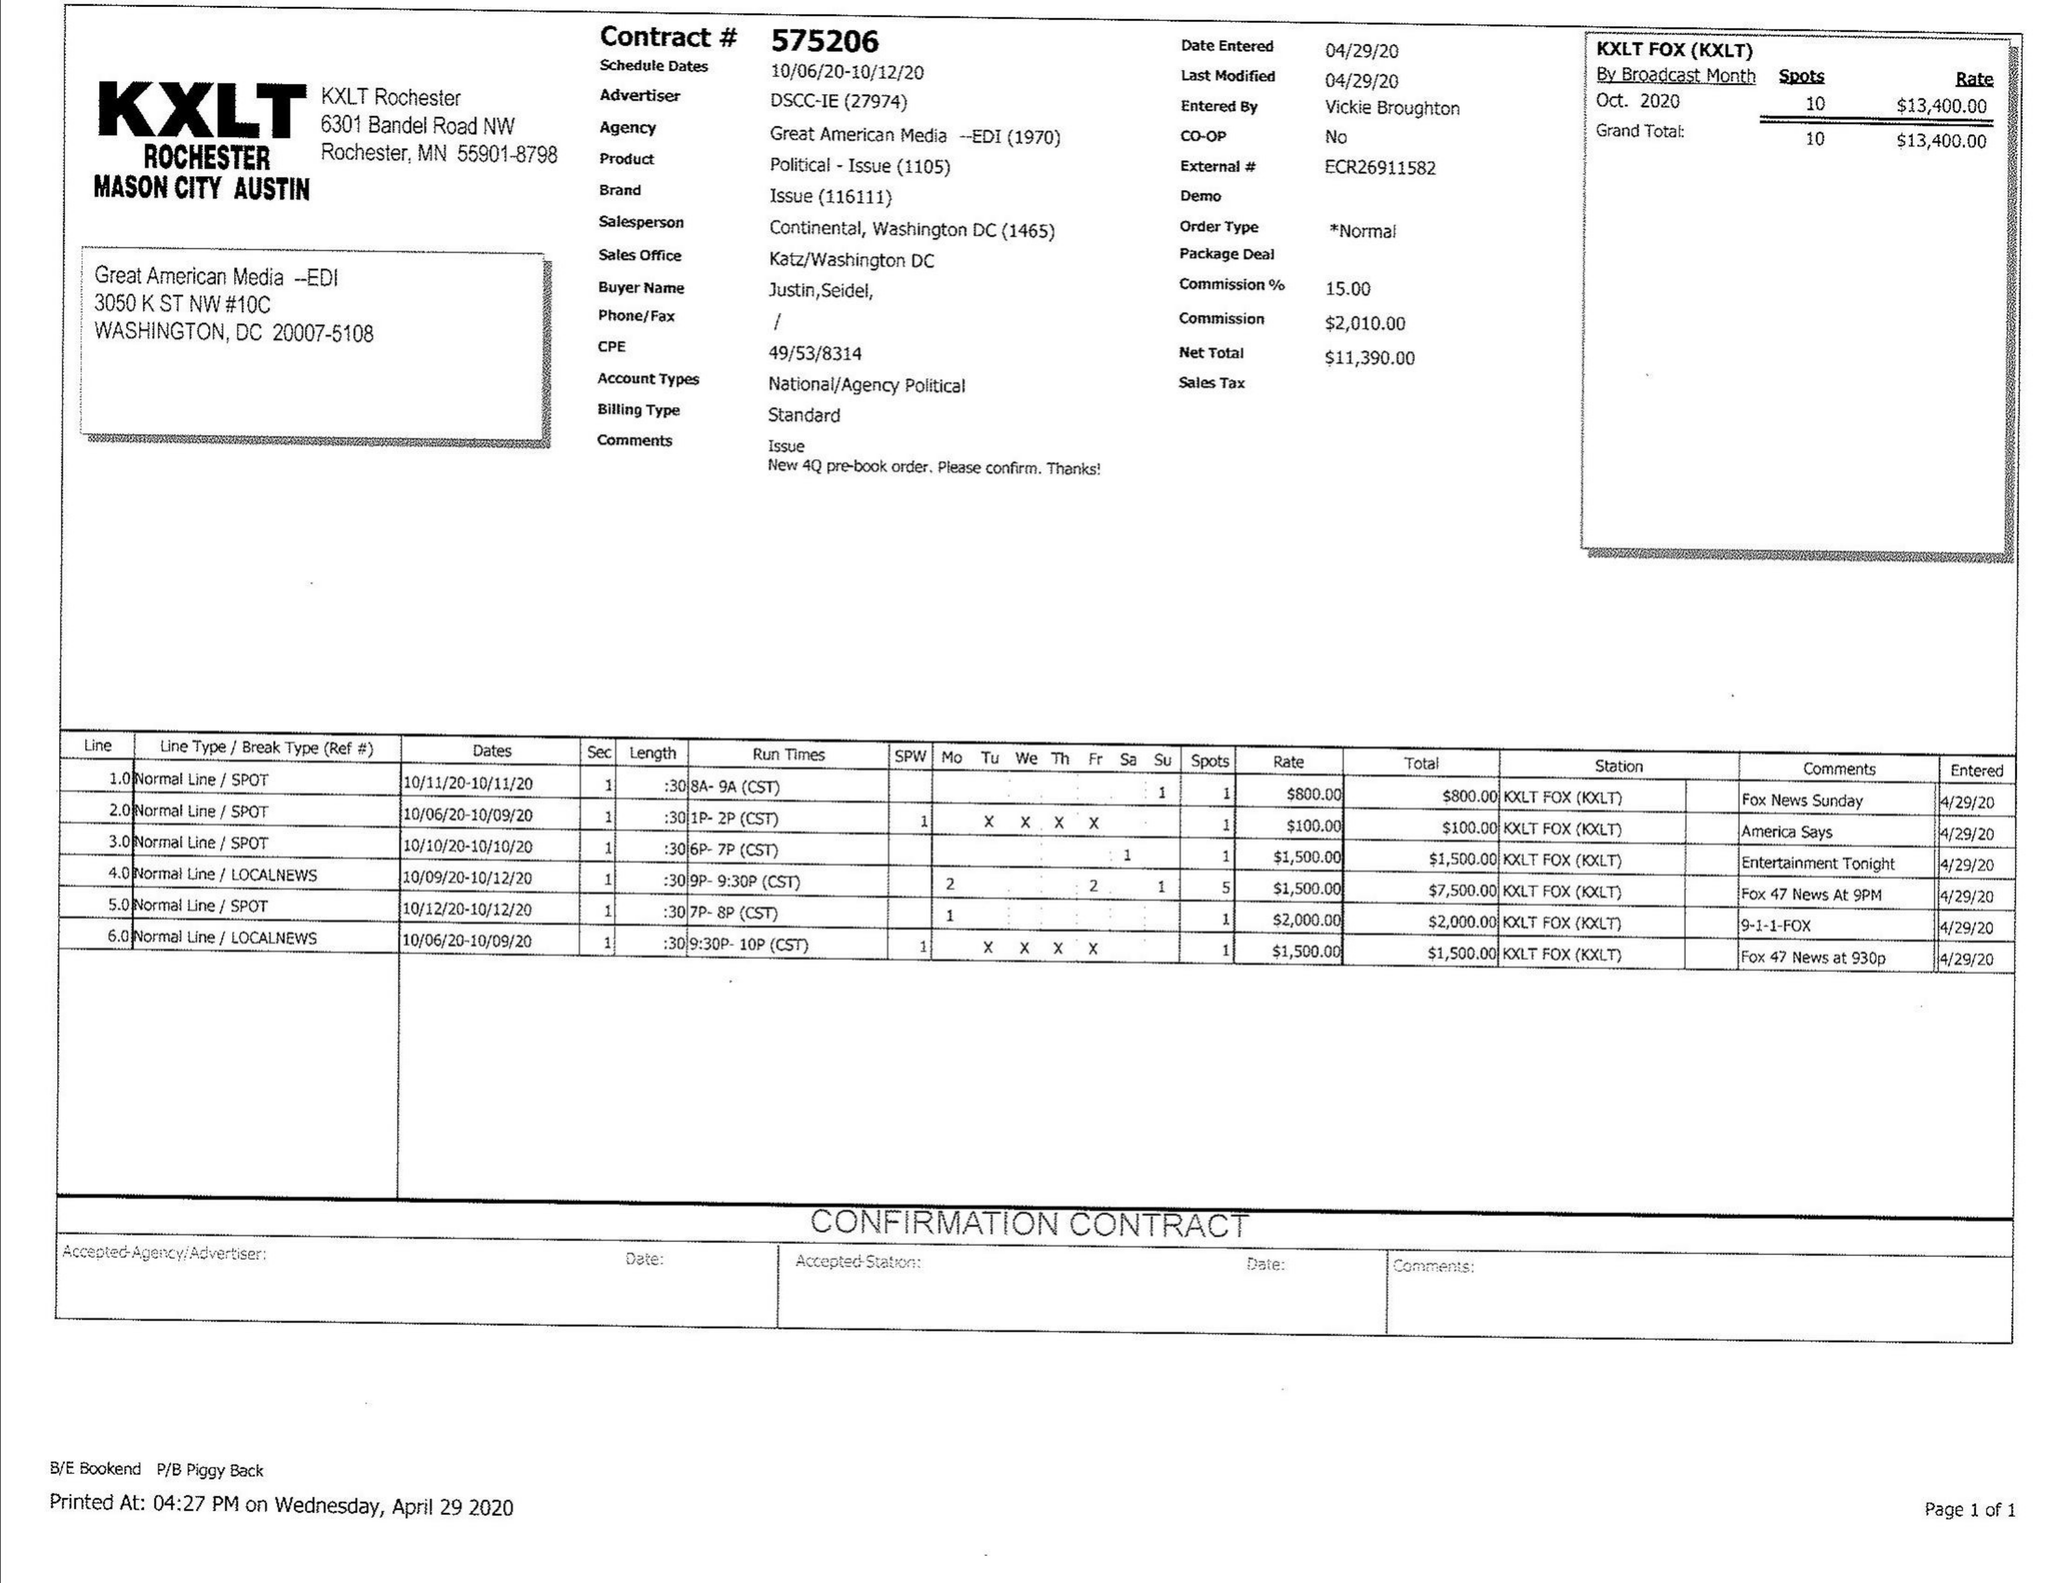What is the value for the contract_num?
Answer the question using a single word or phrase. 575206 